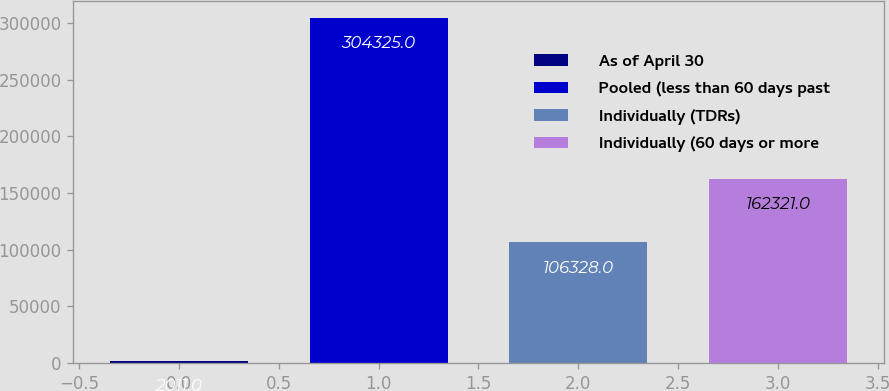Convert chart. <chart><loc_0><loc_0><loc_500><loc_500><bar_chart><fcel>As of April 30<fcel>Pooled (less than 60 days past<fcel>Individually (TDRs)<fcel>Individually (60 days or more<nl><fcel>2011<fcel>304325<fcel>106328<fcel>162321<nl></chart> 